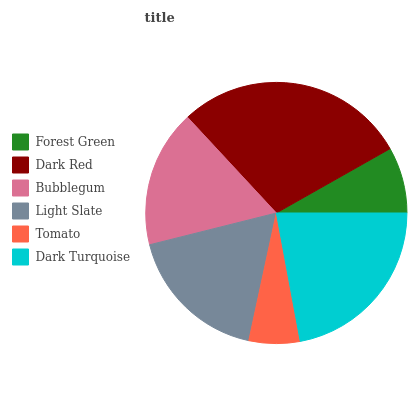Is Tomato the minimum?
Answer yes or no. Yes. Is Dark Red the maximum?
Answer yes or no. Yes. Is Bubblegum the minimum?
Answer yes or no. No. Is Bubblegum the maximum?
Answer yes or no. No. Is Dark Red greater than Bubblegum?
Answer yes or no. Yes. Is Bubblegum less than Dark Red?
Answer yes or no. Yes. Is Bubblegum greater than Dark Red?
Answer yes or no. No. Is Dark Red less than Bubblegum?
Answer yes or no. No. Is Light Slate the high median?
Answer yes or no. Yes. Is Bubblegum the low median?
Answer yes or no. Yes. Is Dark Turquoise the high median?
Answer yes or no. No. Is Tomato the low median?
Answer yes or no. No. 